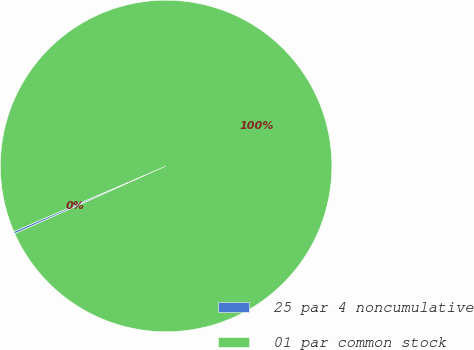Convert chart to OTSL. <chart><loc_0><loc_0><loc_500><loc_500><pie_chart><fcel>25 par 4 noncumulative<fcel>01 par common stock<nl><fcel>0.22%<fcel>99.78%<nl></chart> 